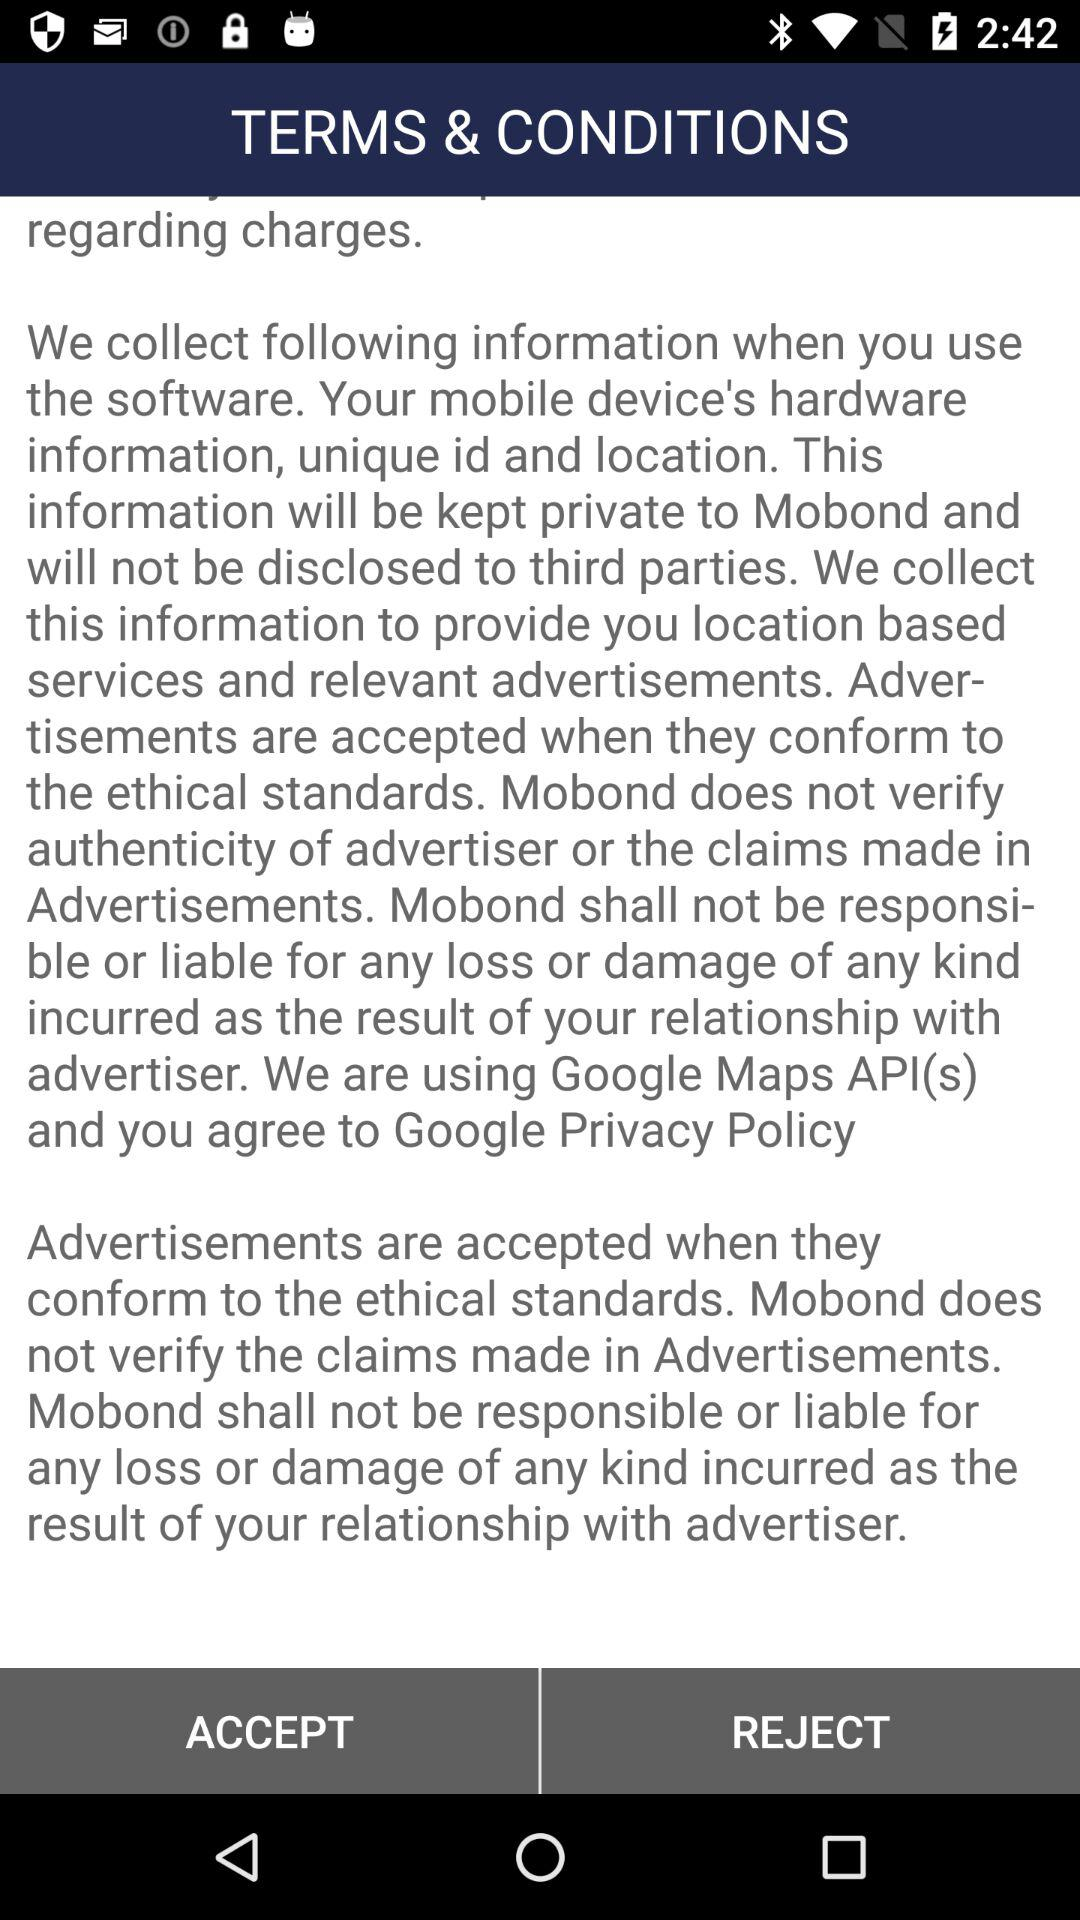When was the western railway timetable last updated? The western railway timetable was last updated in October 2016. 